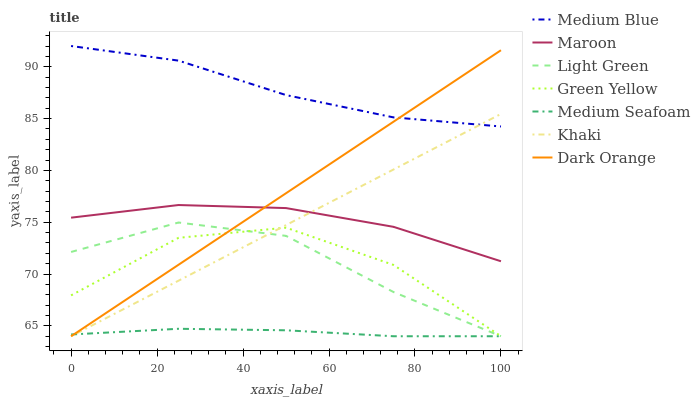Does Khaki have the minimum area under the curve?
Answer yes or no. No. Does Khaki have the maximum area under the curve?
Answer yes or no. No. Is Medium Blue the smoothest?
Answer yes or no. No. Is Medium Blue the roughest?
Answer yes or no. No. Does Medium Blue have the lowest value?
Answer yes or no. No. Does Khaki have the highest value?
Answer yes or no. No. Is Medium Seafoam less than Medium Blue?
Answer yes or no. Yes. Is Maroon greater than Medium Seafoam?
Answer yes or no. Yes. Does Medium Seafoam intersect Medium Blue?
Answer yes or no. No. 